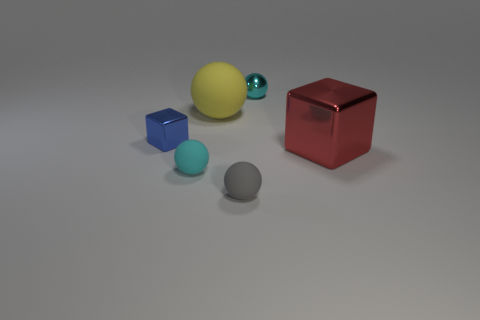Subtract all green cylinders. How many cyan balls are left? 2 Subtract all tiny cyan matte balls. How many balls are left? 3 Subtract all gray spheres. How many spheres are left? 3 Add 1 tiny cubes. How many objects exist? 7 Subtract all purple spheres. Subtract all blue cylinders. How many spheres are left? 4 Subtract all blocks. How many objects are left? 4 Subtract all small red rubber balls. Subtract all tiny matte balls. How many objects are left? 4 Add 5 gray objects. How many gray objects are left? 6 Add 4 tiny cyan rubber balls. How many tiny cyan rubber balls exist? 5 Subtract 0 purple cubes. How many objects are left? 6 